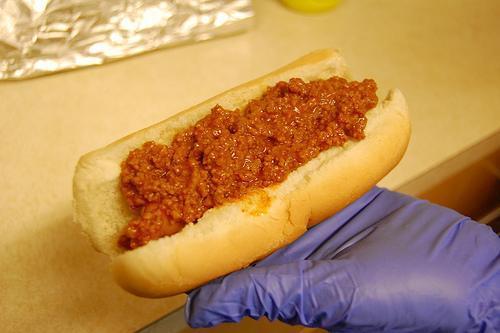How many sloppy joe's are pictured?
Give a very brief answer. 1. 